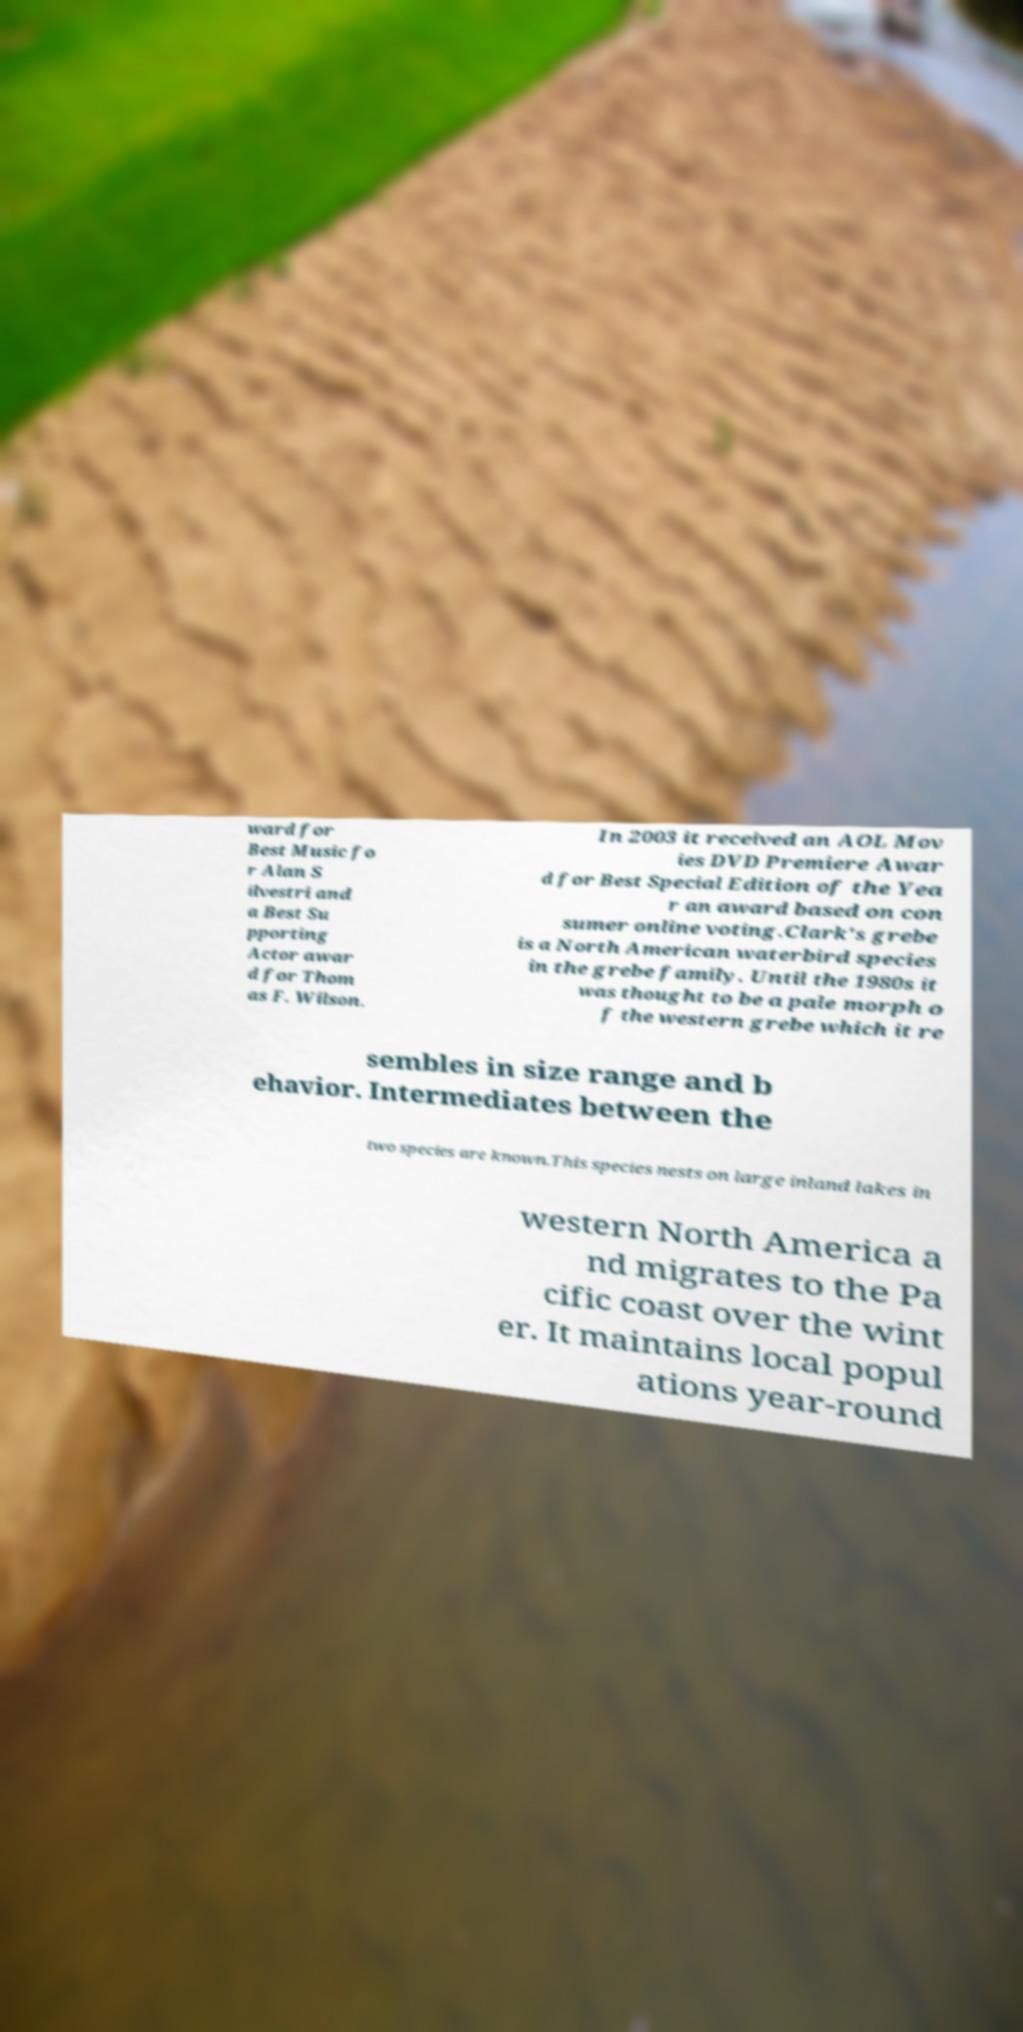What messages or text are displayed in this image? I need them in a readable, typed format. ward for Best Music fo r Alan S ilvestri and a Best Su pporting Actor awar d for Thom as F. Wilson. In 2003 it received an AOL Mov ies DVD Premiere Awar d for Best Special Edition of the Yea r an award based on con sumer online voting.Clark's grebe is a North American waterbird species in the grebe family. Until the 1980s it was thought to be a pale morph o f the western grebe which it re sembles in size range and b ehavior. Intermediates between the two species are known.This species nests on large inland lakes in western North America a nd migrates to the Pa cific coast over the wint er. It maintains local popul ations year-round 